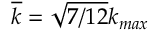<formula> <loc_0><loc_0><loc_500><loc_500>\overline { k } = \sqrt { 7 / 1 2 } k _ { \max }</formula> 